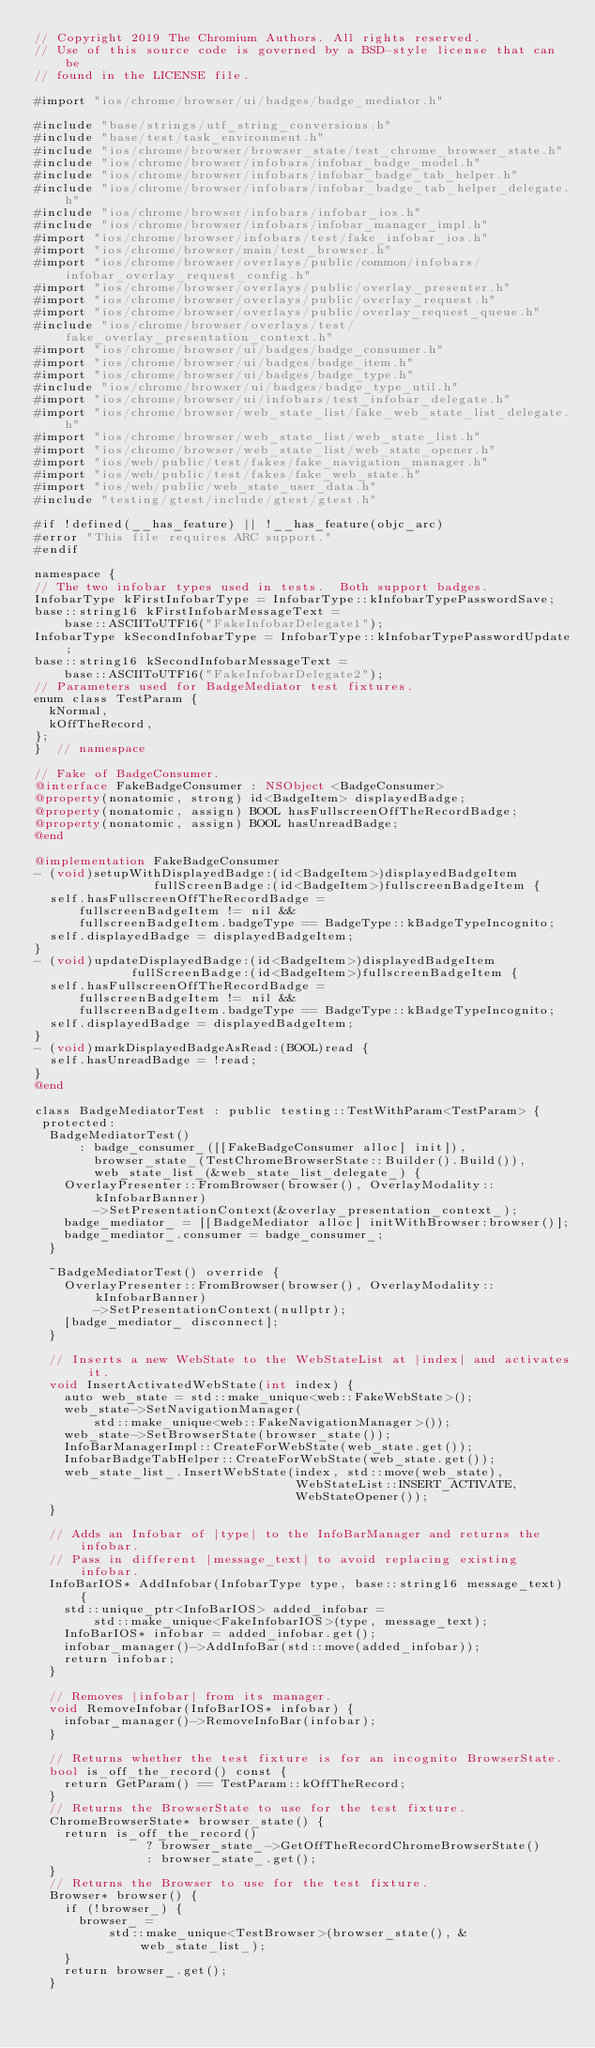<code> <loc_0><loc_0><loc_500><loc_500><_ObjectiveC_>// Copyright 2019 The Chromium Authors. All rights reserved.
// Use of this source code is governed by a BSD-style license that can be
// found in the LICENSE file.

#import "ios/chrome/browser/ui/badges/badge_mediator.h"

#include "base/strings/utf_string_conversions.h"
#include "base/test/task_environment.h"
#include "ios/chrome/browser/browser_state/test_chrome_browser_state.h"
#include "ios/chrome/browser/infobars/infobar_badge_model.h"
#include "ios/chrome/browser/infobars/infobar_badge_tab_helper.h"
#include "ios/chrome/browser/infobars/infobar_badge_tab_helper_delegate.h"
#include "ios/chrome/browser/infobars/infobar_ios.h"
#include "ios/chrome/browser/infobars/infobar_manager_impl.h"
#import "ios/chrome/browser/infobars/test/fake_infobar_ios.h"
#import "ios/chrome/browser/main/test_browser.h"
#import "ios/chrome/browser/overlays/public/common/infobars/infobar_overlay_request_config.h"
#import "ios/chrome/browser/overlays/public/overlay_presenter.h"
#import "ios/chrome/browser/overlays/public/overlay_request.h"
#import "ios/chrome/browser/overlays/public/overlay_request_queue.h"
#include "ios/chrome/browser/overlays/test/fake_overlay_presentation_context.h"
#import "ios/chrome/browser/ui/badges/badge_consumer.h"
#import "ios/chrome/browser/ui/badges/badge_item.h"
#import "ios/chrome/browser/ui/badges/badge_type.h"
#include "ios/chrome/browser/ui/badges/badge_type_util.h"
#import "ios/chrome/browser/ui/infobars/test_infobar_delegate.h"
#import "ios/chrome/browser/web_state_list/fake_web_state_list_delegate.h"
#import "ios/chrome/browser/web_state_list/web_state_list.h"
#import "ios/chrome/browser/web_state_list/web_state_opener.h"
#import "ios/web/public/test/fakes/fake_navigation_manager.h"
#import "ios/web/public/test/fakes/fake_web_state.h"
#import "ios/web/public/web_state_user_data.h"
#include "testing/gtest/include/gtest/gtest.h"

#if !defined(__has_feature) || !__has_feature(objc_arc)
#error "This file requires ARC support."
#endif

namespace {
// The two infobar types used in tests.  Both support badges.
InfobarType kFirstInfobarType = InfobarType::kInfobarTypePasswordSave;
base::string16 kFirstInfobarMessageText =
    base::ASCIIToUTF16("FakeInfobarDelegate1");
InfobarType kSecondInfobarType = InfobarType::kInfobarTypePasswordUpdate;
base::string16 kSecondInfobarMessageText =
    base::ASCIIToUTF16("FakeInfobarDelegate2");
// Parameters used for BadgeMediator test fixtures.
enum class TestParam {
  kNormal,
  kOffTheRecord,
};
}  // namespace

// Fake of BadgeConsumer.
@interface FakeBadgeConsumer : NSObject <BadgeConsumer>
@property(nonatomic, strong) id<BadgeItem> displayedBadge;
@property(nonatomic, assign) BOOL hasFullscreenOffTheRecordBadge;
@property(nonatomic, assign) BOOL hasUnreadBadge;
@end

@implementation FakeBadgeConsumer
- (void)setupWithDisplayedBadge:(id<BadgeItem>)displayedBadgeItem
                fullScreenBadge:(id<BadgeItem>)fullscreenBadgeItem {
  self.hasFullscreenOffTheRecordBadge =
      fullscreenBadgeItem != nil &&
      fullscreenBadgeItem.badgeType == BadgeType::kBadgeTypeIncognito;
  self.displayedBadge = displayedBadgeItem;
}
- (void)updateDisplayedBadge:(id<BadgeItem>)displayedBadgeItem
             fullScreenBadge:(id<BadgeItem>)fullscreenBadgeItem {
  self.hasFullscreenOffTheRecordBadge =
      fullscreenBadgeItem != nil &&
      fullscreenBadgeItem.badgeType == BadgeType::kBadgeTypeIncognito;
  self.displayedBadge = displayedBadgeItem;
}
- (void)markDisplayedBadgeAsRead:(BOOL)read {
  self.hasUnreadBadge = !read;
}
@end

class BadgeMediatorTest : public testing::TestWithParam<TestParam> {
 protected:
  BadgeMediatorTest()
      : badge_consumer_([[FakeBadgeConsumer alloc] init]),
        browser_state_(TestChromeBrowserState::Builder().Build()),
        web_state_list_(&web_state_list_delegate_) {
    OverlayPresenter::FromBrowser(browser(), OverlayModality::kInfobarBanner)
        ->SetPresentationContext(&overlay_presentation_context_);
    badge_mediator_ = [[BadgeMediator alloc] initWithBrowser:browser()];
    badge_mediator_.consumer = badge_consumer_;
  }

  ~BadgeMediatorTest() override {
    OverlayPresenter::FromBrowser(browser(), OverlayModality::kInfobarBanner)
        ->SetPresentationContext(nullptr);
    [badge_mediator_ disconnect];
  }

  // Inserts a new WebState to the WebStateList at |index| and activates it.
  void InsertActivatedWebState(int index) {
    auto web_state = std::make_unique<web::FakeWebState>();
    web_state->SetNavigationManager(
        std::make_unique<web::FakeNavigationManager>());
    web_state->SetBrowserState(browser_state());
    InfoBarManagerImpl::CreateForWebState(web_state.get());
    InfobarBadgeTabHelper::CreateForWebState(web_state.get());
    web_state_list_.InsertWebState(index, std::move(web_state),
                                   WebStateList::INSERT_ACTIVATE,
                                   WebStateOpener());
  }

  // Adds an Infobar of |type| to the InfoBarManager and returns the infobar.
  // Pass in different |message_text| to avoid replacing existing infobar.
  InfoBarIOS* AddInfobar(InfobarType type, base::string16 message_text) {
    std::unique_ptr<InfoBarIOS> added_infobar =
        std::make_unique<FakeInfobarIOS>(type, message_text);
    InfoBarIOS* infobar = added_infobar.get();
    infobar_manager()->AddInfoBar(std::move(added_infobar));
    return infobar;
  }

  // Removes |infobar| from its manager.
  void RemoveInfobar(InfoBarIOS* infobar) {
    infobar_manager()->RemoveInfoBar(infobar);
  }

  // Returns whether the test fixture is for an incognito BrowserState.
  bool is_off_the_record() const {
    return GetParam() == TestParam::kOffTheRecord;
  }
  // Returns the BrowserState to use for the test fixture.
  ChromeBrowserState* browser_state() {
    return is_off_the_record()
               ? browser_state_->GetOffTheRecordChromeBrowserState()
               : browser_state_.get();
  }
  // Returns the Browser to use for the test fixture.
  Browser* browser() {
    if (!browser_) {
      browser_ =
          std::make_unique<TestBrowser>(browser_state(), &web_state_list_);
    }
    return browser_.get();
  }</code> 